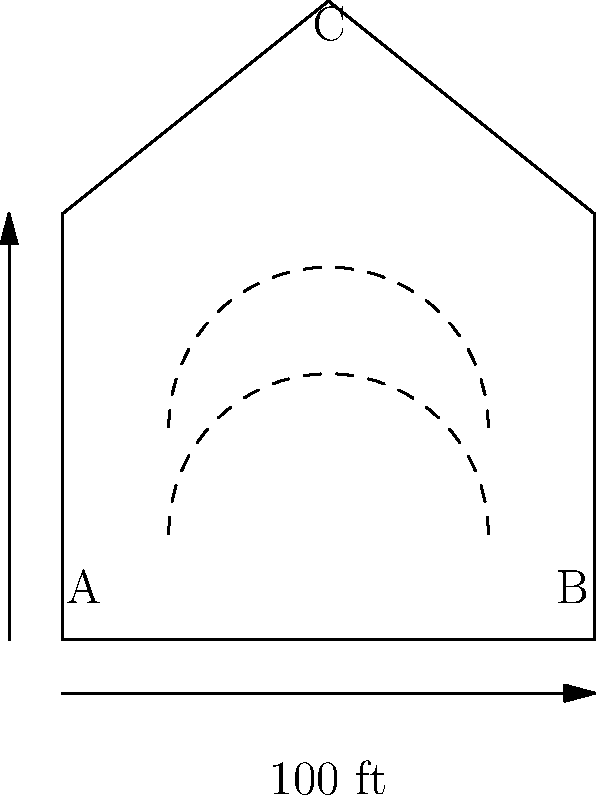In the cross-sectional diagram of your church sanctuary above, sound waves are shown traveling from point A to point B. Considering the shape of the ceiling, what acoustic phenomenon is likely to occur at point C, and how might this affect the overall sound quality in the sanctuary? To answer this question, let's analyze the diagram and consider the principles of acoustics:

1. The church sanctuary has a peaked ceiling, forming a triangular shape at the top.

2. Sound waves are shown traveling from point A to point B, representing the path from a sound source (e.g., a choir or speaker) to a listener.

3. Point C is located at the apex of the ceiling.

4. In acoustics, when sound waves encounter a surface, they can be reflected, absorbed, or diffused.

5. The peaked ceiling creates what's known as a focusing effect. Sound waves that hit this angled surface are likely to be reflected and concentrated towards a specific area.

6. This phenomenon is called sound focusing or acoustic focusing. It occurs when sound waves are reflected off curved or angled surfaces in a way that concentrates them at a particular point.

7. At point C, sound waves from various directions are likely to converge, creating a focal point.

8. The effect on sound quality can be significant:
   a) It may create "hot spots" where sound is much louder or more intense.
   b) It can lead to uneven sound distribution throughout the sanctuary.
   c) It might cause echoes or reverberations that interfere with clarity.

9. For a choir leader, this could mean that the sound heard in different parts of the sanctuary varies greatly, potentially affecting the perceived quality and balance of the choir's performance.
Answer: Acoustic focusing at point C, causing uneven sound distribution and potential echoes. 